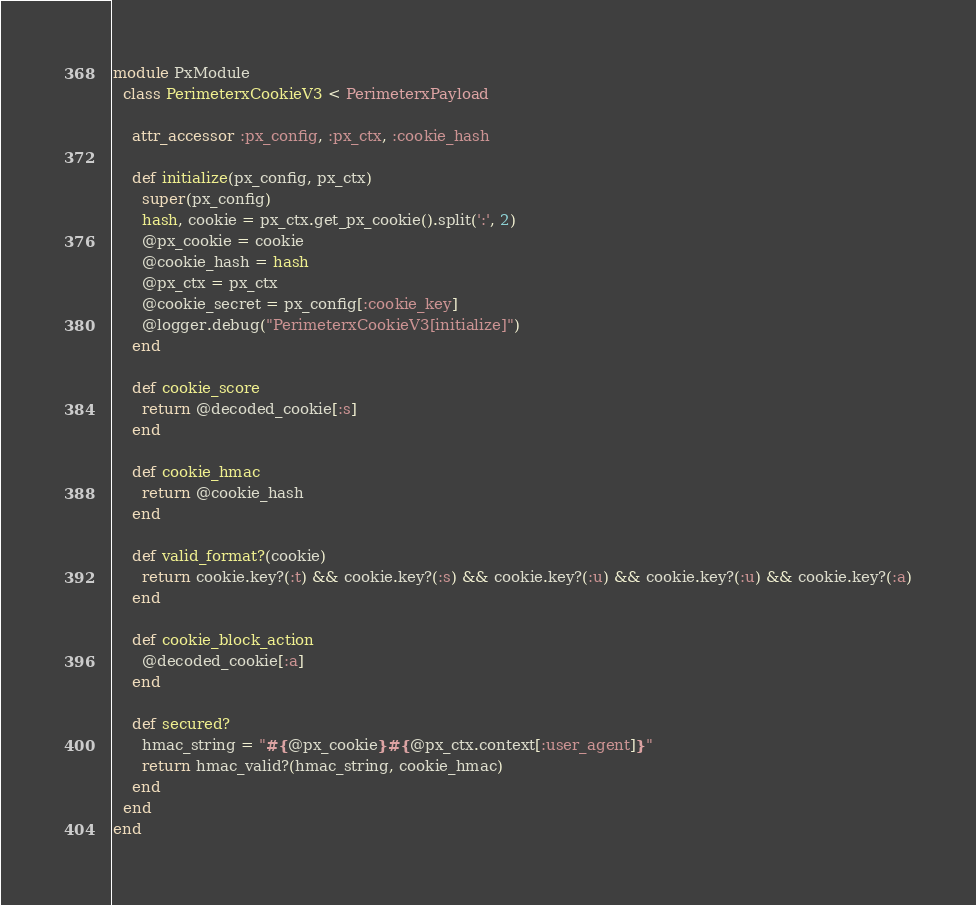<code> <loc_0><loc_0><loc_500><loc_500><_Ruby_>module PxModule
  class PerimeterxCookieV3 < PerimeterxPayload

    attr_accessor :px_config, :px_ctx, :cookie_hash

    def initialize(px_config, px_ctx)
      super(px_config)
      hash, cookie = px_ctx.get_px_cookie().split(':', 2)
      @px_cookie = cookie
      @cookie_hash = hash
      @px_ctx = px_ctx
      @cookie_secret = px_config[:cookie_key]
      @logger.debug("PerimeterxCookieV3[initialize]")
    end

    def cookie_score
      return @decoded_cookie[:s]
    end

    def cookie_hmac
      return @cookie_hash
    end

    def valid_format?(cookie)
      return cookie.key?(:t) && cookie.key?(:s) && cookie.key?(:u) && cookie.key?(:u) && cookie.key?(:a)
    end

    def cookie_block_action
      @decoded_cookie[:a]
    end

    def secured?
      hmac_string = "#{@px_cookie}#{@px_ctx.context[:user_agent]}"
      return hmac_valid?(hmac_string, cookie_hmac)
    end
  end
end
</code> 